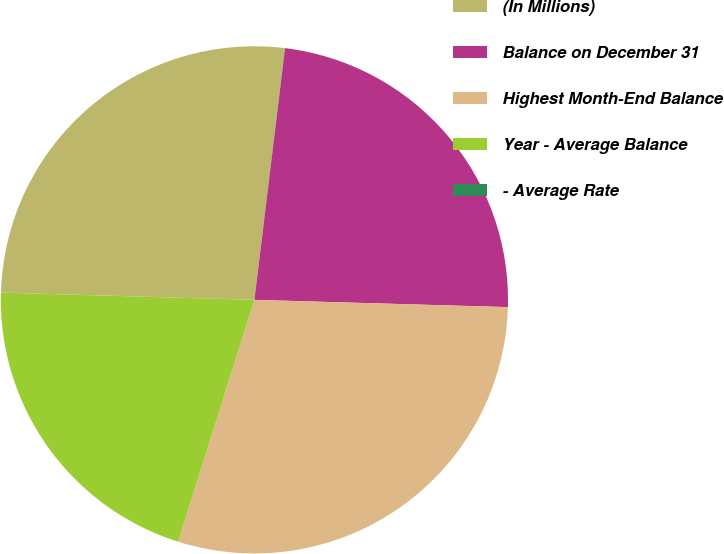Convert chart to OTSL. <chart><loc_0><loc_0><loc_500><loc_500><pie_chart><fcel>(In Millions)<fcel>Balance on December 31<fcel>Highest Month-End Balance<fcel>Year - Average Balance<fcel>- Average Rate<nl><fcel>26.47%<fcel>23.53%<fcel>29.41%<fcel>20.59%<fcel>0.0%<nl></chart> 